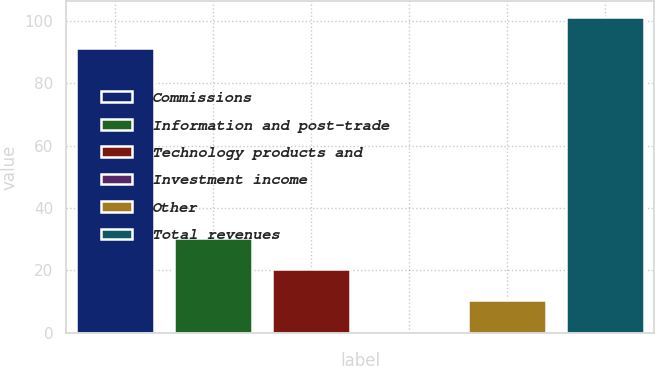<chart> <loc_0><loc_0><loc_500><loc_500><bar_chart><fcel>Commissions<fcel>Information and post-trade<fcel>Technology products and<fcel>Investment income<fcel>Other<fcel>Total revenues<nl><fcel>91.3<fcel>30.42<fcel>20.48<fcel>0.6<fcel>10.54<fcel>101.24<nl></chart> 